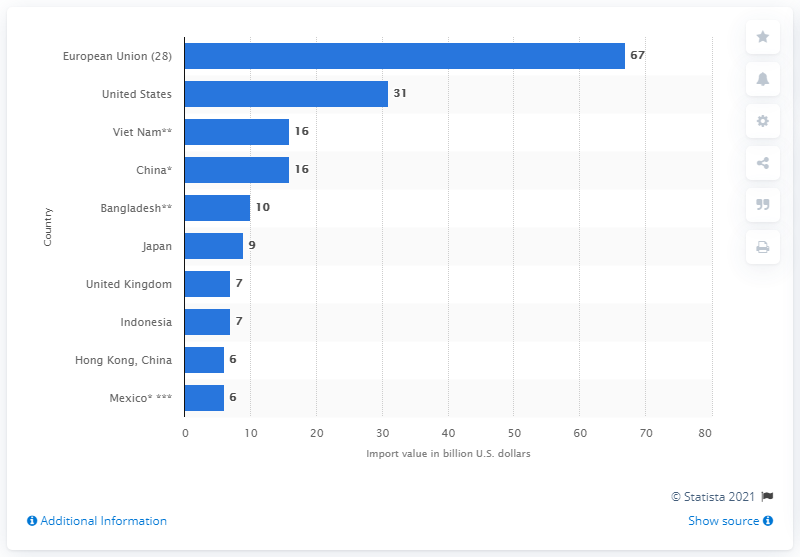Mention a couple of crucial points in this snapshot. In 2019, the value of textile imports by the EU28 was approximately 67 billion US dollars. 